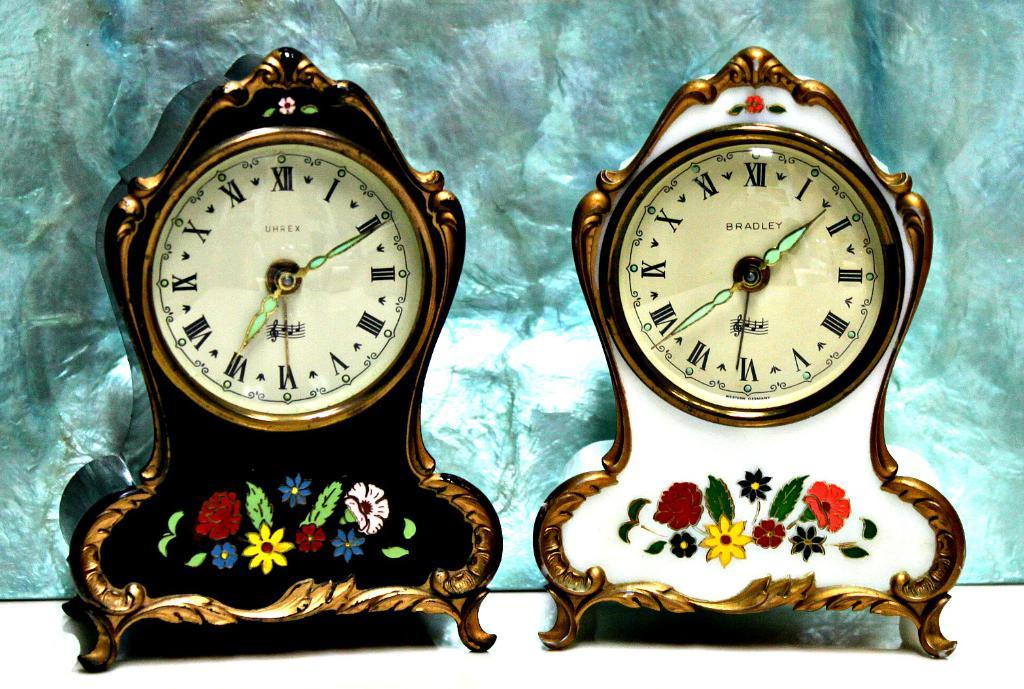<image>
Describe the image concisely. A Umrex clock is next to a Bradley clock, and both are decorated with painted flowers. 